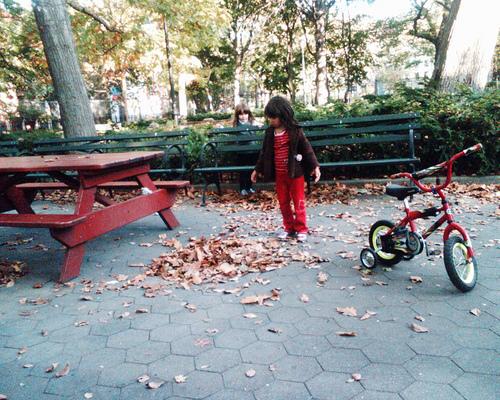Does this bike have training wheels?
Give a very brief answer. Yes. How many girls are visible?
Be succinct. 2. Is the picnic table red?
Answer briefly. Yes. 